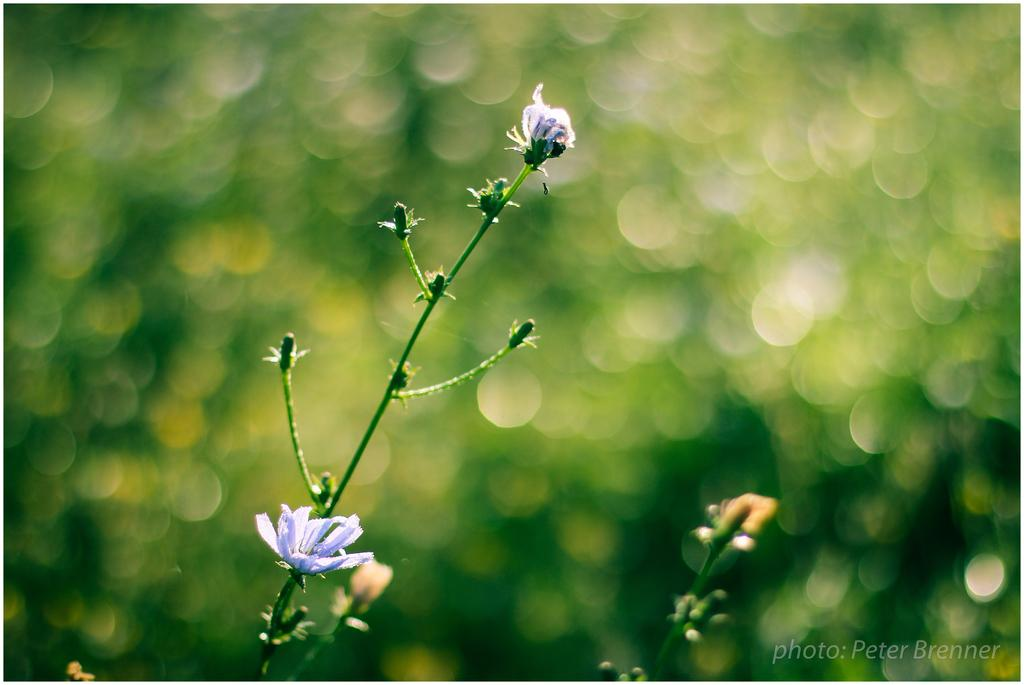What type of vegetation can be seen on the branches in the image? There are flowers and buds on the branches in the image. How would you describe the background of the image? The background is blurred. Is there any additional information or marking on the image? Yes, there is a watermark on the image. What type of flag is visible in the image? There is no flag present in the image. Where might the basin be located in the image? There is no basin present in the image. 